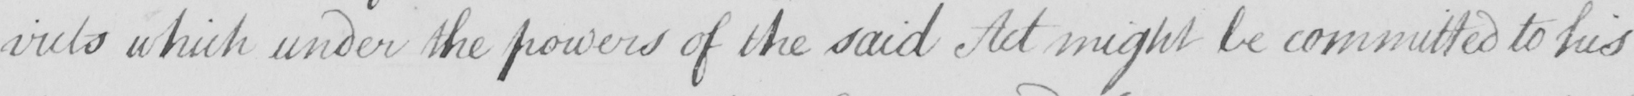Please transcribe the handwritten text in this image. -victs which under the powers of the said Act might be committed to his 